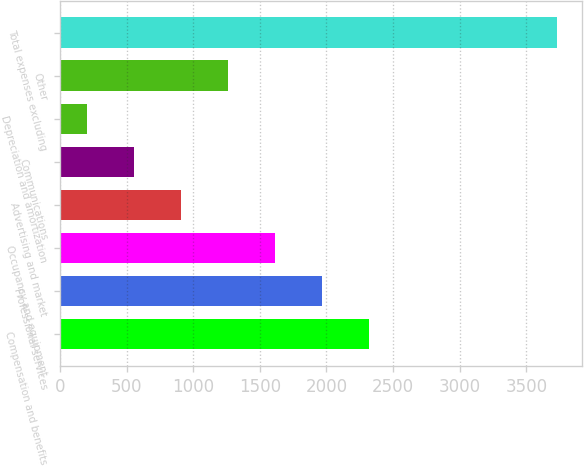Convert chart. <chart><loc_0><loc_0><loc_500><loc_500><bar_chart><fcel>Compensation and benefits<fcel>Professional services<fcel>Occupancy and equipment<fcel>Advertising and market<fcel>Communications<fcel>Depreciation and amortization<fcel>Other<fcel>Total expenses excluding<nl><fcel>2318.8<fcel>1966<fcel>1613.2<fcel>907.6<fcel>554.8<fcel>202<fcel>1260.4<fcel>3730<nl></chart> 